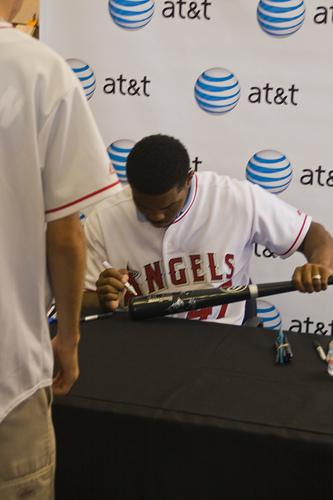What is the seated man's profession? baseball player 